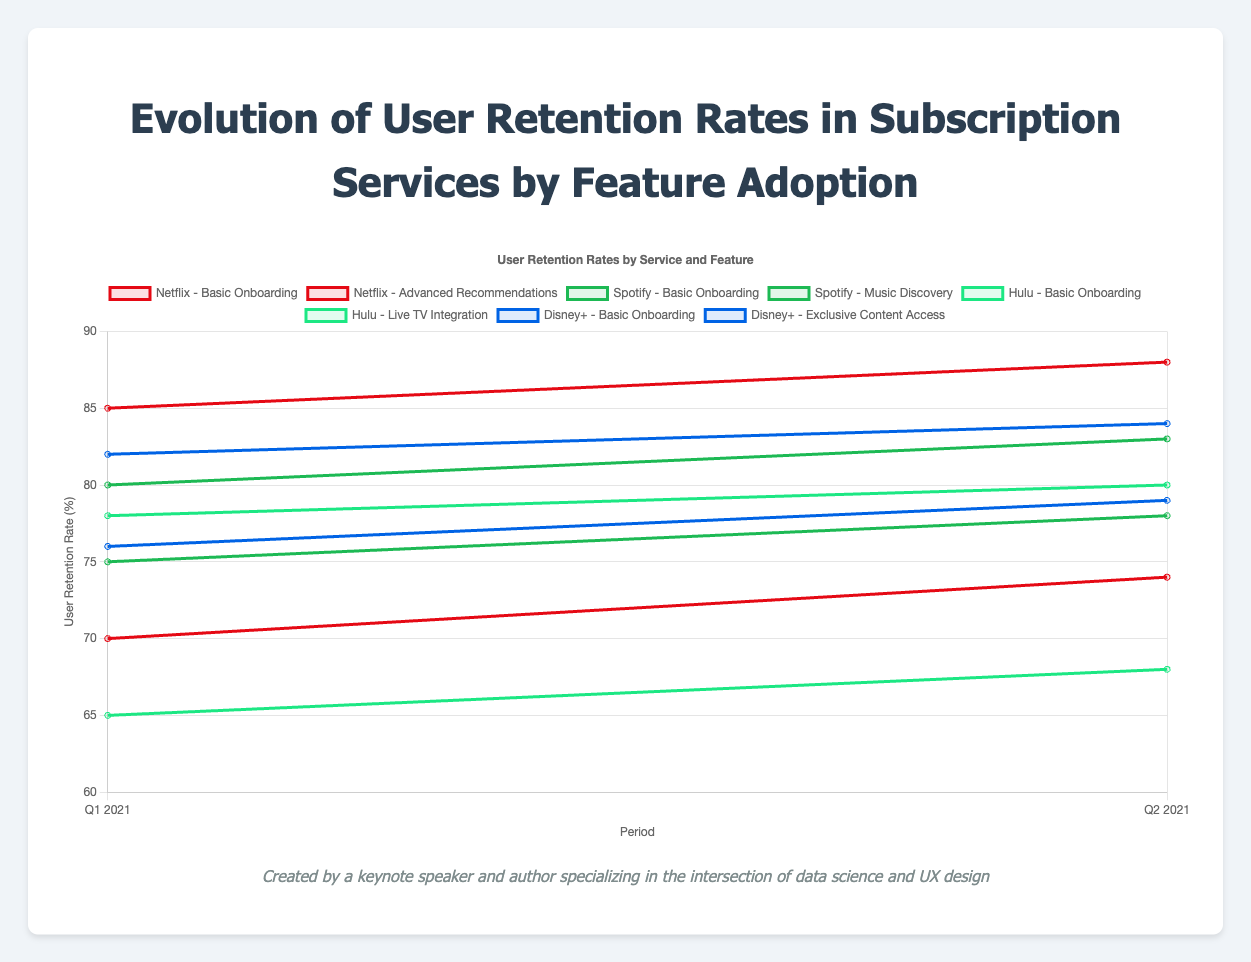Which feature had the highest user retention rate for Netflix in Q2 2021? Look at the Netflix data for Q2 2021. "Basic Onboarding" has a retention rate of 88%, while "Advanced Recommendations" has 74%.
Answer: Basic Onboarding Compare user retention rates for "Basic Onboarding" in Q1 & Q2 2021 across all services. Which service showed the greatest increase? Compare the Q1 and Q2 2021 retention rates for "Basic Onboarding" for Netflix (85% to 88%), Spotify (80% to 83%), Hulu (78% to 80%), and Disney+ (82% to 84%). Spotify has an increase of 3%, the greatest among all.
Answer: Spotify What is the average user retention rate for "Music Discovery" feature on Spotify across Q1 and Q2 2021? The retention rates for "Music Discovery" on Spotify are 75% for Q1 2021 and 78% for Q2 2021. The average is (75% + 78%)/2 = 76.5%.
Answer: 76.5% Which feature for Hulu had the lowest user retention rate in Q1 2021, and what was the percentage? For Hulu in Q1 2021, "Basic Onboarding" had a retention rate of 78%, and "Live TV Integration" had 65%. So, "Live TV Integration" had the lowest rate.
Answer: Live TV Integration, 65% Compare the user retention improvement from Q1 to Q2 2021 between "Advanced Recommendations" on Netflix and "Live TV Integration" on Hulu. Which one improved more? The retention rate for "Advanced Recommendations" on Netflix went from 70% to 74%, an increase of 4%. For "Live TV Integration" on Hulu, it went from 65% to 68%, an increase of 3%. Therefore, Netflix improved more.
Answer: Advanced Recommendations on Netflix For Disney+, what is the difference in Q1 2021 user retention rates between "Basic Onboarding" and "Exclusive Content Access"? For Disney+ in Q1 2021, "Basic Onboarding" had an 82% retention rate, and "Exclusive Content Access" had 76%. The difference is 82% - 76% = 6%.
Answer: 6% Determine the trend of user retention rates for "Basic Onboarding" on Netflix between Q1 and Q2 2021. "Basic Onboarding" on Netflix shows an increasing trend from 85% in Q1 to 88% in Q2 2021.
Answer: Increasing What is the range of user retention rates for the "Live TV Integration" feature on Hulu across Q1 and Q2 2021? The retention rates for "Live TV Integration" on Hulu are 65% in Q1 and 68% in Q2 2021. The range is 68% - 65% = 3%.
Answer: 3% Which service had the highest user retention rate for their respective features in Q1 2021? For Q1 2021, Netflix (85% for "Basic Onboarding"), Spotify (80% for "Basic Onboarding"), Hulu (78% for "Basic Onboarding"), Disney+ (82% for "Basic Onboarding"). Netflix had the highest with 85%.
Answer: Netflix 